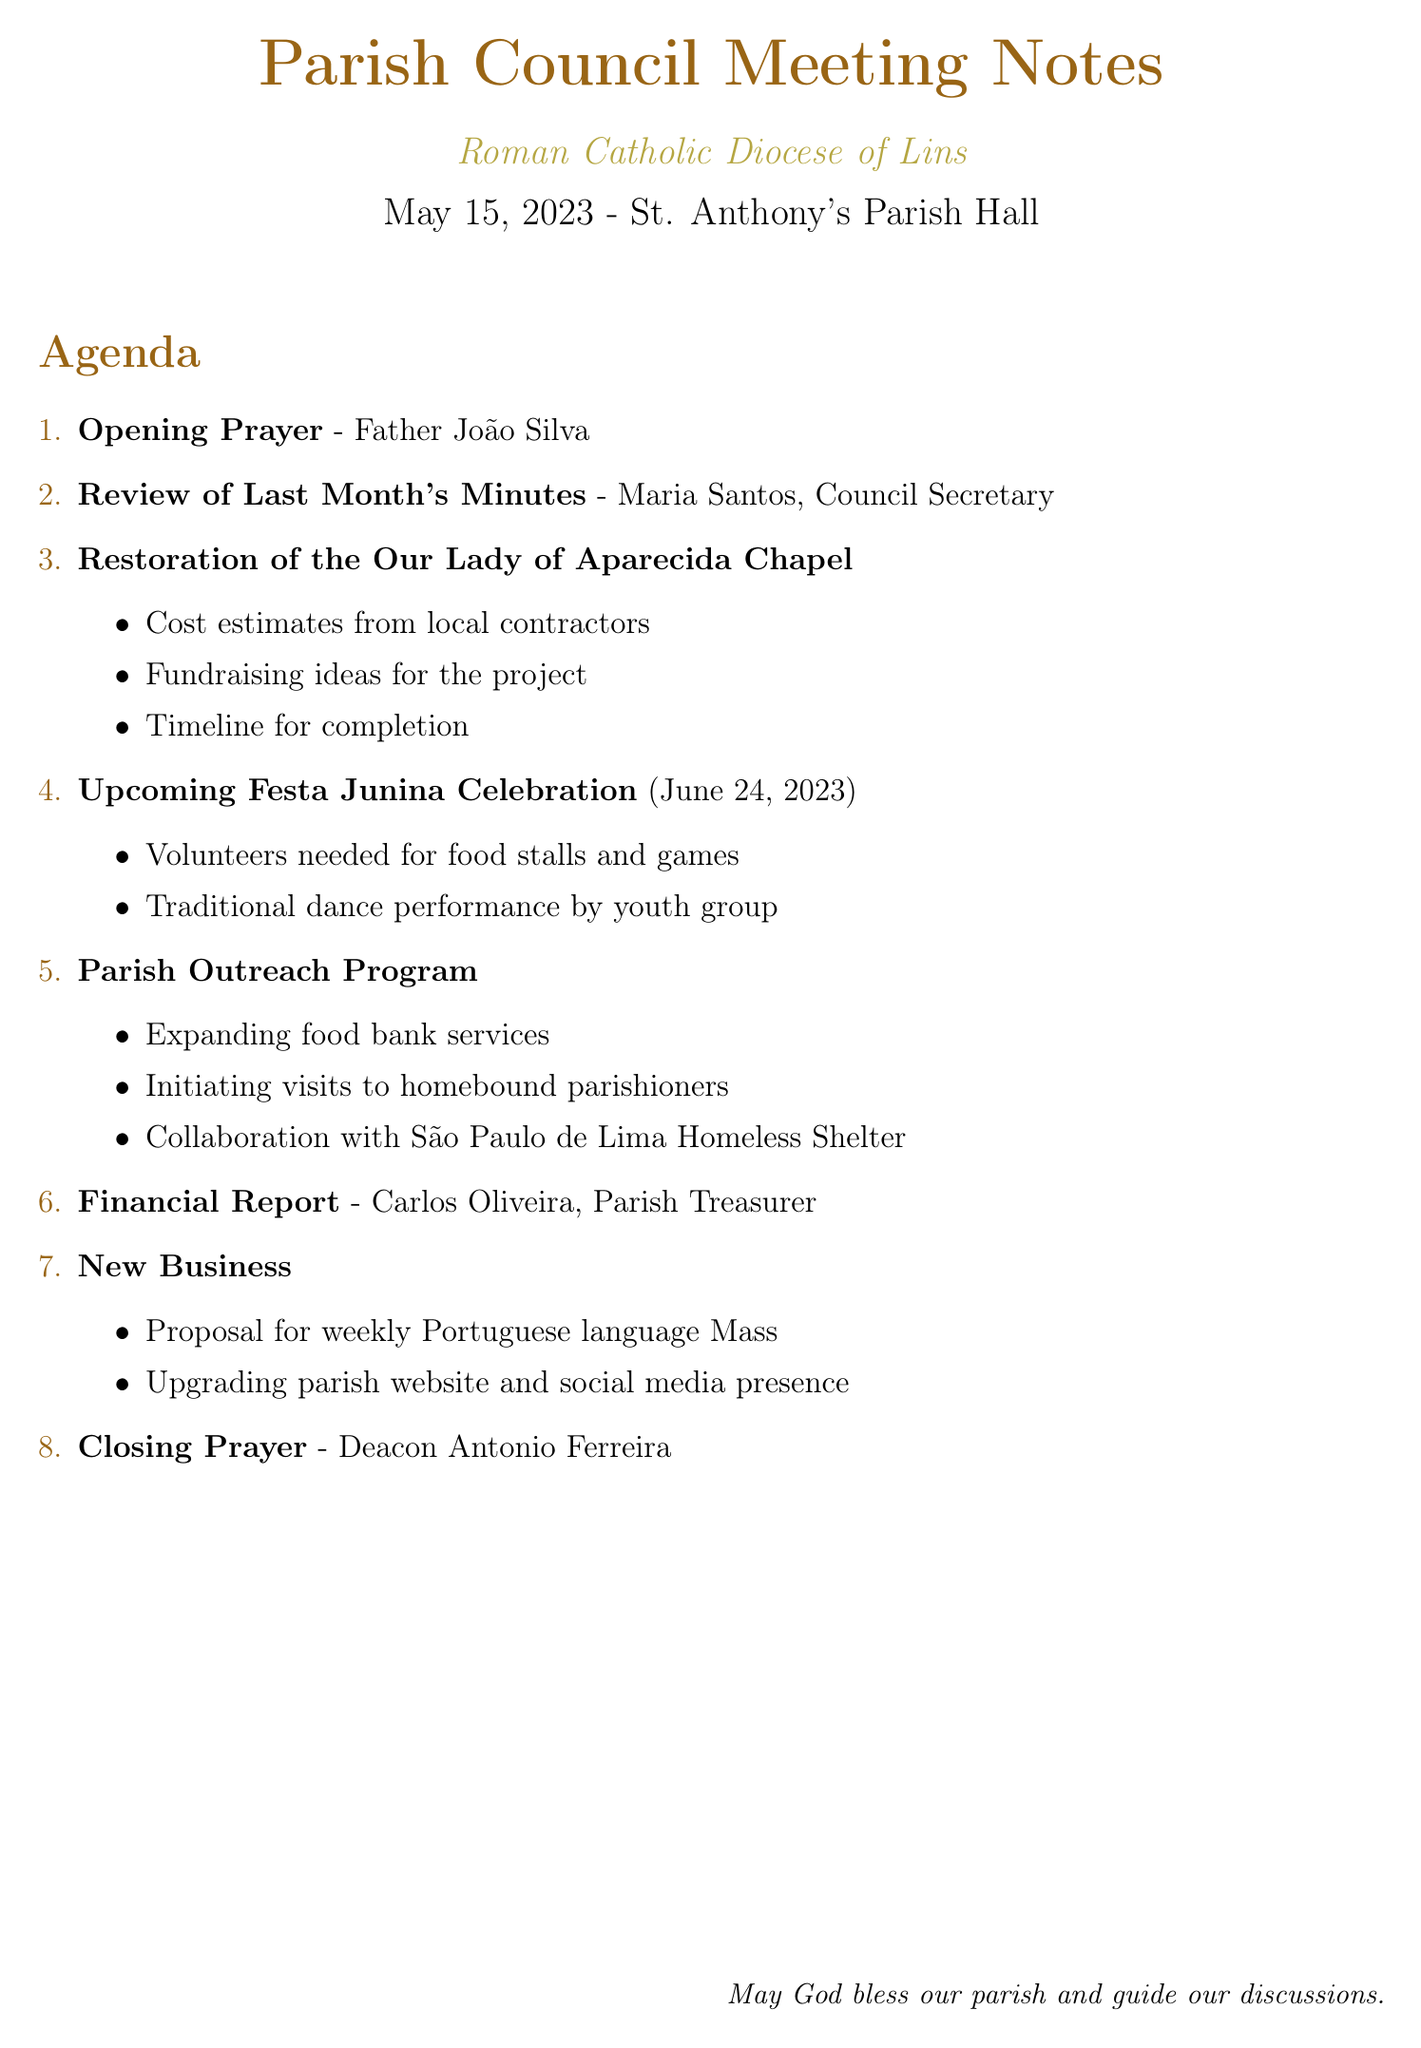What is the date of the meeting? The date of the meeting is specified in the document as May 15, 2023.
Answer: May 15, 2023 Where is the meeting location? The location of the meeting is indicated in the document as St. Anthony's Parish Hall.
Answer: St. Anthony's Parish Hall Who is leading the opening prayer? The document lists Father João Silva as the leader of the opening prayer.
Answer: Father João Silva What is the date of the Upcoming Festa Junina Celebration? The document mentions the date for the Upcoming Festa Junina Celebration as June 24, 2023.
Answer: June 24, 2023 What topic is presented by Carlos Oliveira? Carlos Oliveira is the presenter of the Financial Report as indicated in the agenda section.
Answer: Financial Report What are two items discussed under the Parish Outreach Program? The document lists expanding food bank services and initiating visits to homebound parishioners as details in the Parish Outreach Program.
Answer: Expanding food bank services, initiating visits to homebound parishioners What is a new business proposal mentioned in the agenda? The agenda includes a proposal for a weekly Portuguese language Mass as part of new business.
Answer: Weekly Portuguese language Mass Who leads the closing prayer? The document states that Deacon Antonio Ferreira leads the closing prayer.
Answer: Deacon Antonio Ferreira 